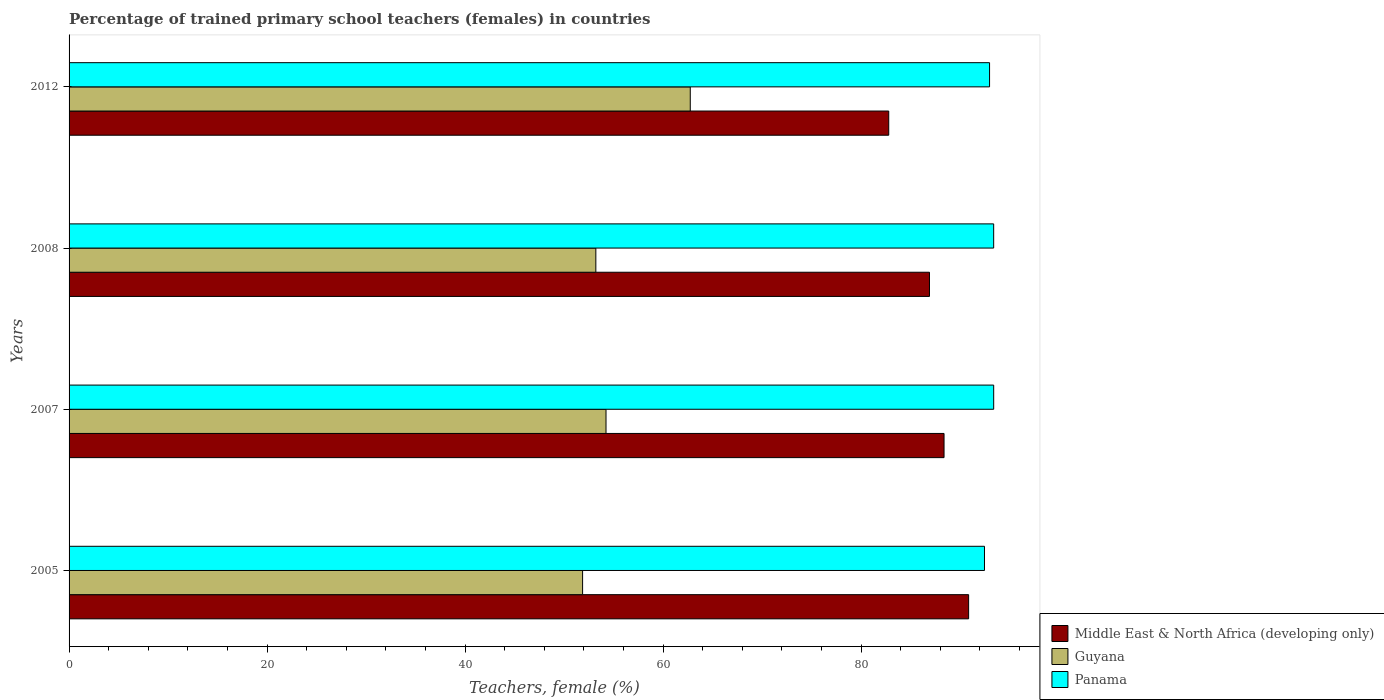Are the number of bars on each tick of the Y-axis equal?
Give a very brief answer. Yes. How many bars are there on the 3rd tick from the top?
Ensure brevity in your answer.  3. What is the label of the 4th group of bars from the top?
Give a very brief answer. 2005. What is the percentage of trained primary school teachers (females) in Guyana in 2008?
Your answer should be compact. 53.2. Across all years, what is the maximum percentage of trained primary school teachers (females) in Guyana?
Give a very brief answer. 62.74. Across all years, what is the minimum percentage of trained primary school teachers (females) in Guyana?
Give a very brief answer. 51.87. In which year was the percentage of trained primary school teachers (females) in Panama maximum?
Ensure brevity in your answer.  2007. What is the total percentage of trained primary school teachers (females) in Middle East & North Africa (developing only) in the graph?
Provide a succinct answer. 348.91. What is the difference between the percentage of trained primary school teachers (females) in Guyana in 2005 and that in 2008?
Make the answer very short. -1.34. What is the difference between the percentage of trained primary school teachers (females) in Guyana in 2008 and the percentage of trained primary school teachers (females) in Middle East & North Africa (developing only) in 2007?
Ensure brevity in your answer.  -35.17. What is the average percentage of trained primary school teachers (females) in Middle East & North Africa (developing only) per year?
Keep it short and to the point. 87.23. In the year 2012, what is the difference between the percentage of trained primary school teachers (females) in Guyana and percentage of trained primary school teachers (females) in Middle East & North Africa (developing only)?
Ensure brevity in your answer.  -20.05. What is the ratio of the percentage of trained primary school teachers (females) in Guyana in 2005 to that in 2008?
Provide a short and direct response. 0.97. Is the difference between the percentage of trained primary school teachers (females) in Guyana in 2005 and 2007 greater than the difference between the percentage of trained primary school teachers (females) in Middle East & North Africa (developing only) in 2005 and 2007?
Provide a short and direct response. No. What is the difference between the highest and the second highest percentage of trained primary school teachers (females) in Middle East & North Africa (developing only)?
Keep it short and to the point. 2.48. What is the difference between the highest and the lowest percentage of trained primary school teachers (females) in Panama?
Make the answer very short. 0.93. In how many years, is the percentage of trained primary school teachers (females) in Guyana greater than the average percentage of trained primary school teachers (females) in Guyana taken over all years?
Offer a terse response. 1. What does the 3rd bar from the top in 2008 represents?
Your response must be concise. Middle East & North Africa (developing only). What does the 3rd bar from the bottom in 2012 represents?
Your answer should be very brief. Panama. Is it the case that in every year, the sum of the percentage of trained primary school teachers (females) in Panama and percentage of trained primary school teachers (females) in Middle East & North Africa (developing only) is greater than the percentage of trained primary school teachers (females) in Guyana?
Provide a short and direct response. Yes. How many bars are there?
Give a very brief answer. 12. Are all the bars in the graph horizontal?
Give a very brief answer. Yes. How many years are there in the graph?
Ensure brevity in your answer.  4. What is the difference between two consecutive major ticks on the X-axis?
Provide a short and direct response. 20. Are the values on the major ticks of X-axis written in scientific E-notation?
Keep it short and to the point. No. Where does the legend appear in the graph?
Offer a very short reply. Bottom right. What is the title of the graph?
Your response must be concise. Percentage of trained primary school teachers (females) in countries. What is the label or title of the X-axis?
Ensure brevity in your answer.  Teachers, female (%). What is the label or title of the Y-axis?
Ensure brevity in your answer.  Years. What is the Teachers, female (%) of Middle East & North Africa (developing only) in 2005?
Your response must be concise. 90.85. What is the Teachers, female (%) of Guyana in 2005?
Your answer should be very brief. 51.87. What is the Teachers, female (%) in Panama in 2005?
Your answer should be compact. 92.46. What is the Teachers, female (%) in Middle East & North Africa (developing only) in 2007?
Your answer should be compact. 88.37. What is the Teachers, female (%) in Guyana in 2007?
Ensure brevity in your answer.  54.23. What is the Teachers, female (%) of Panama in 2007?
Keep it short and to the point. 93.39. What is the Teachers, female (%) in Middle East & North Africa (developing only) in 2008?
Offer a very short reply. 86.9. What is the Teachers, female (%) in Guyana in 2008?
Keep it short and to the point. 53.2. What is the Teachers, female (%) of Panama in 2008?
Your response must be concise. 93.38. What is the Teachers, female (%) of Middle East & North Africa (developing only) in 2012?
Provide a short and direct response. 82.79. What is the Teachers, female (%) of Guyana in 2012?
Offer a very short reply. 62.74. What is the Teachers, female (%) in Panama in 2012?
Your answer should be very brief. 92.97. Across all years, what is the maximum Teachers, female (%) of Middle East & North Africa (developing only)?
Offer a terse response. 90.85. Across all years, what is the maximum Teachers, female (%) in Guyana?
Your response must be concise. 62.74. Across all years, what is the maximum Teachers, female (%) of Panama?
Offer a terse response. 93.39. Across all years, what is the minimum Teachers, female (%) in Middle East & North Africa (developing only)?
Make the answer very short. 82.79. Across all years, what is the minimum Teachers, female (%) in Guyana?
Offer a very short reply. 51.87. Across all years, what is the minimum Teachers, female (%) in Panama?
Keep it short and to the point. 92.46. What is the total Teachers, female (%) in Middle East & North Africa (developing only) in the graph?
Give a very brief answer. 348.91. What is the total Teachers, female (%) in Guyana in the graph?
Keep it short and to the point. 222.04. What is the total Teachers, female (%) in Panama in the graph?
Your answer should be compact. 372.19. What is the difference between the Teachers, female (%) of Middle East & North Africa (developing only) in 2005 and that in 2007?
Your answer should be very brief. 2.48. What is the difference between the Teachers, female (%) of Guyana in 2005 and that in 2007?
Ensure brevity in your answer.  -2.37. What is the difference between the Teachers, female (%) of Panama in 2005 and that in 2007?
Your response must be concise. -0.93. What is the difference between the Teachers, female (%) in Middle East & North Africa (developing only) in 2005 and that in 2008?
Give a very brief answer. 3.95. What is the difference between the Teachers, female (%) in Guyana in 2005 and that in 2008?
Provide a short and direct response. -1.34. What is the difference between the Teachers, female (%) of Panama in 2005 and that in 2008?
Offer a very short reply. -0.93. What is the difference between the Teachers, female (%) in Middle East & North Africa (developing only) in 2005 and that in 2012?
Offer a very short reply. 8.07. What is the difference between the Teachers, female (%) of Guyana in 2005 and that in 2012?
Provide a succinct answer. -10.88. What is the difference between the Teachers, female (%) in Panama in 2005 and that in 2012?
Ensure brevity in your answer.  -0.51. What is the difference between the Teachers, female (%) in Middle East & North Africa (developing only) in 2007 and that in 2008?
Provide a succinct answer. 1.47. What is the difference between the Teachers, female (%) of Guyana in 2007 and that in 2008?
Offer a very short reply. 1.03. What is the difference between the Teachers, female (%) of Panama in 2007 and that in 2008?
Provide a short and direct response. 0. What is the difference between the Teachers, female (%) of Middle East & North Africa (developing only) in 2007 and that in 2012?
Your answer should be compact. 5.59. What is the difference between the Teachers, female (%) of Guyana in 2007 and that in 2012?
Offer a very short reply. -8.51. What is the difference between the Teachers, female (%) of Panama in 2007 and that in 2012?
Provide a short and direct response. 0.42. What is the difference between the Teachers, female (%) in Middle East & North Africa (developing only) in 2008 and that in 2012?
Offer a terse response. 4.12. What is the difference between the Teachers, female (%) in Guyana in 2008 and that in 2012?
Ensure brevity in your answer.  -9.54. What is the difference between the Teachers, female (%) of Panama in 2008 and that in 2012?
Ensure brevity in your answer.  0.41. What is the difference between the Teachers, female (%) in Middle East & North Africa (developing only) in 2005 and the Teachers, female (%) in Guyana in 2007?
Your answer should be compact. 36.62. What is the difference between the Teachers, female (%) of Middle East & North Africa (developing only) in 2005 and the Teachers, female (%) of Panama in 2007?
Your answer should be compact. -2.53. What is the difference between the Teachers, female (%) of Guyana in 2005 and the Teachers, female (%) of Panama in 2007?
Provide a short and direct response. -41.52. What is the difference between the Teachers, female (%) in Middle East & North Africa (developing only) in 2005 and the Teachers, female (%) in Guyana in 2008?
Offer a very short reply. 37.65. What is the difference between the Teachers, female (%) in Middle East & North Africa (developing only) in 2005 and the Teachers, female (%) in Panama in 2008?
Your answer should be very brief. -2.53. What is the difference between the Teachers, female (%) in Guyana in 2005 and the Teachers, female (%) in Panama in 2008?
Provide a succinct answer. -41.52. What is the difference between the Teachers, female (%) in Middle East & North Africa (developing only) in 2005 and the Teachers, female (%) in Guyana in 2012?
Provide a short and direct response. 28.11. What is the difference between the Teachers, female (%) in Middle East & North Africa (developing only) in 2005 and the Teachers, female (%) in Panama in 2012?
Your answer should be compact. -2.12. What is the difference between the Teachers, female (%) in Guyana in 2005 and the Teachers, female (%) in Panama in 2012?
Give a very brief answer. -41.1. What is the difference between the Teachers, female (%) of Middle East & North Africa (developing only) in 2007 and the Teachers, female (%) of Guyana in 2008?
Give a very brief answer. 35.17. What is the difference between the Teachers, female (%) in Middle East & North Africa (developing only) in 2007 and the Teachers, female (%) in Panama in 2008?
Give a very brief answer. -5.01. What is the difference between the Teachers, female (%) of Guyana in 2007 and the Teachers, female (%) of Panama in 2008?
Your response must be concise. -39.15. What is the difference between the Teachers, female (%) of Middle East & North Africa (developing only) in 2007 and the Teachers, female (%) of Guyana in 2012?
Your answer should be very brief. 25.63. What is the difference between the Teachers, female (%) of Middle East & North Africa (developing only) in 2007 and the Teachers, female (%) of Panama in 2012?
Offer a terse response. -4.6. What is the difference between the Teachers, female (%) in Guyana in 2007 and the Teachers, female (%) in Panama in 2012?
Make the answer very short. -38.74. What is the difference between the Teachers, female (%) of Middle East & North Africa (developing only) in 2008 and the Teachers, female (%) of Guyana in 2012?
Your response must be concise. 24.16. What is the difference between the Teachers, female (%) in Middle East & North Africa (developing only) in 2008 and the Teachers, female (%) in Panama in 2012?
Make the answer very short. -6.07. What is the difference between the Teachers, female (%) in Guyana in 2008 and the Teachers, female (%) in Panama in 2012?
Provide a short and direct response. -39.77. What is the average Teachers, female (%) in Middle East & North Africa (developing only) per year?
Provide a succinct answer. 87.23. What is the average Teachers, female (%) of Guyana per year?
Offer a very short reply. 55.51. What is the average Teachers, female (%) in Panama per year?
Your response must be concise. 93.05. In the year 2005, what is the difference between the Teachers, female (%) of Middle East & North Africa (developing only) and Teachers, female (%) of Guyana?
Give a very brief answer. 38.99. In the year 2005, what is the difference between the Teachers, female (%) of Middle East & North Africa (developing only) and Teachers, female (%) of Panama?
Keep it short and to the point. -1.6. In the year 2005, what is the difference between the Teachers, female (%) in Guyana and Teachers, female (%) in Panama?
Ensure brevity in your answer.  -40.59. In the year 2007, what is the difference between the Teachers, female (%) of Middle East & North Africa (developing only) and Teachers, female (%) of Guyana?
Provide a short and direct response. 34.14. In the year 2007, what is the difference between the Teachers, female (%) in Middle East & North Africa (developing only) and Teachers, female (%) in Panama?
Offer a very short reply. -5.01. In the year 2007, what is the difference between the Teachers, female (%) of Guyana and Teachers, female (%) of Panama?
Your response must be concise. -39.15. In the year 2008, what is the difference between the Teachers, female (%) of Middle East & North Africa (developing only) and Teachers, female (%) of Guyana?
Your answer should be very brief. 33.7. In the year 2008, what is the difference between the Teachers, female (%) of Middle East & North Africa (developing only) and Teachers, female (%) of Panama?
Your response must be concise. -6.48. In the year 2008, what is the difference between the Teachers, female (%) in Guyana and Teachers, female (%) in Panama?
Keep it short and to the point. -40.18. In the year 2012, what is the difference between the Teachers, female (%) in Middle East & North Africa (developing only) and Teachers, female (%) in Guyana?
Offer a very short reply. 20.05. In the year 2012, what is the difference between the Teachers, female (%) of Middle East & North Africa (developing only) and Teachers, female (%) of Panama?
Your answer should be very brief. -10.18. In the year 2012, what is the difference between the Teachers, female (%) of Guyana and Teachers, female (%) of Panama?
Your answer should be compact. -30.23. What is the ratio of the Teachers, female (%) of Middle East & North Africa (developing only) in 2005 to that in 2007?
Make the answer very short. 1.03. What is the ratio of the Teachers, female (%) of Guyana in 2005 to that in 2007?
Your answer should be compact. 0.96. What is the ratio of the Teachers, female (%) in Panama in 2005 to that in 2007?
Your answer should be compact. 0.99. What is the ratio of the Teachers, female (%) in Middle East & North Africa (developing only) in 2005 to that in 2008?
Ensure brevity in your answer.  1.05. What is the ratio of the Teachers, female (%) of Guyana in 2005 to that in 2008?
Offer a very short reply. 0.97. What is the ratio of the Teachers, female (%) of Middle East & North Africa (developing only) in 2005 to that in 2012?
Offer a very short reply. 1.1. What is the ratio of the Teachers, female (%) of Guyana in 2005 to that in 2012?
Your answer should be very brief. 0.83. What is the ratio of the Teachers, female (%) in Middle East & North Africa (developing only) in 2007 to that in 2008?
Make the answer very short. 1.02. What is the ratio of the Teachers, female (%) of Guyana in 2007 to that in 2008?
Ensure brevity in your answer.  1.02. What is the ratio of the Teachers, female (%) in Middle East & North Africa (developing only) in 2007 to that in 2012?
Provide a short and direct response. 1.07. What is the ratio of the Teachers, female (%) in Guyana in 2007 to that in 2012?
Your answer should be compact. 0.86. What is the ratio of the Teachers, female (%) in Panama in 2007 to that in 2012?
Your answer should be very brief. 1. What is the ratio of the Teachers, female (%) of Middle East & North Africa (developing only) in 2008 to that in 2012?
Offer a very short reply. 1.05. What is the ratio of the Teachers, female (%) of Guyana in 2008 to that in 2012?
Ensure brevity in your answer.  0.85. What is the difference between the highest and the second highest Teachers, female (%) in Middle East & North Africa (developing only)?
Give a very brief answer. 2.48. What is the difference between the highest and the second highest Teachers, female (%) of Guyana?
Your answer should be very brief. 8.51. What is the difference between the highest and the second highest Teachers, female (%) in Panama?
Keep it short and to the point. 0. What is the difference between the highest and the lowest Teachers, female (%) of Middle East & North Africa (developing only)?
Keep it short and to the point. 8.07. What is the difference between the highest and the lowest Teachers, female (%) in Guyana?
Provide a succinct answer. 10.88. What is the difference between the highest and the lowest Teachers, female (%) in Panama?
Offer a very short reply. 0.93. 